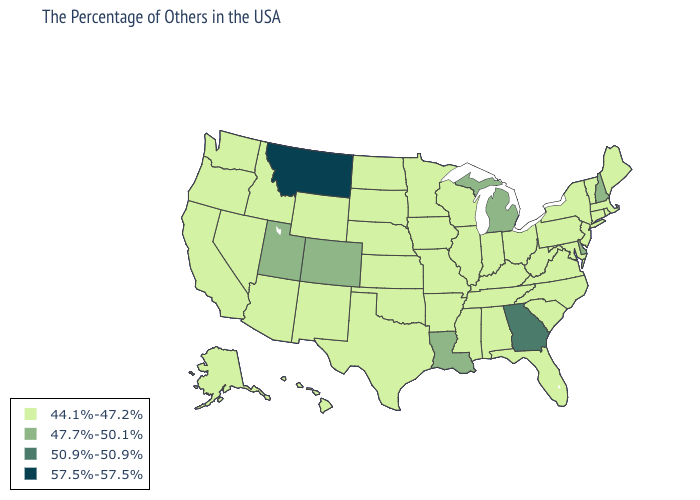Does Louisiana have the highest value in the South?
Answer briefly. No. What is the lowest value in states that border Tennessee?
Short answer required. 44.1%-47.2%. Name the states that have a value in the range 44.1%-47.2%?
Write a very short answer. Maine, Massachusetts, Rhode Island, Vermont, Connecticut, New York, New Jersey, Maryland, Pennsylvania, Virginia, North Carolina, South Carolina, West Virginia, Ohio, Florida, Kentucky, Indiana, Alabama, Tennessee, Wisconsin, Illinois, Mississippi, Missouri, Arkansas, Minnesota, Iowa, Kansas, Nebraska, Oklahoma, Texas, South Dakota, North Dakota, Wyoming, New Mexico, Arizona, Idaho, Nevada, California, Washington, Oregon, Alaska, Hawaii. Name the states that have a value in the range 44.1%-47.2%?
Be succinct. Maine, Massachusetts, Rhode Island, Vermont, Connecticut, New York, New Jersey, Maryland, Pennsylvania, Virginia, North Carolina, South Carolina, West Virginia, Ohio, Florida, Kentucky, Indiana, Alabama, Tennessee, Wisconsin, Illinois, Mississippi, Missouri, Arkansas, Minnesota, Iowa, Kansas, Nebraska, Oklahoma, Texas, South Dakota, North Dakota, Wyoming, New Mexico, Arizona, Idaho, Nevada, California, Washington, Oregon, Alaska, Hawaii. Name the states that have a value in the range 57.5%-57.5%?
Keep it brief. Montana. What is the lowest value in the USA?
Keep it brief. 44.1%-47.2%. What is the value of Rhode Island?
Concise answer only. 44.1%-47.2%. What is the value of Nebraska?
Give a very brief answer. 44.1%-47.2%. Name the states that have a value in the range 57.5%-57.5%?
Short answer required. Montana. Among the states that border Washington , which have the lowest value?
Write a very short answer. Idaho, Oregon. Name the states that have a value in the range 57.5%-57.5%?
Concise answer only. Montana. What is the value of New Mexico?
Write a very short answer. 44.1%-47.2%. Which states hav the highest value in the Northeast?
Short answer required. New Hampshire. Does South Carolina have the same value as Illinois?
Quick response, please. Yes. 